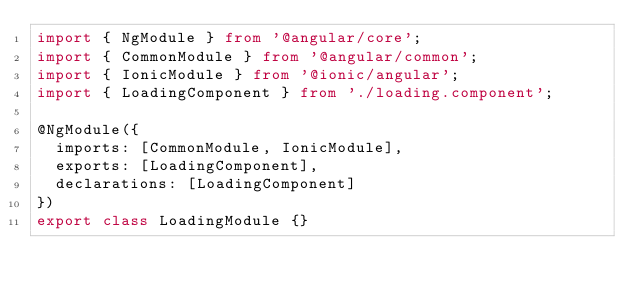<code> <loc_0><loc_0><loc_500><loc_500><_TypeScript_>import { NgModule } from '@angular/core';
import { CommonModule } from '@angular/common';
import { IonicModule } from '@ionic/angular';
import { LoadingComponent } from './loading.component';

@NgModule({
	imports: [CommonModule, IonicModule],
	exports: [LoadingComponent],
	declarations: [LoadingComponent]
})
export class LoadingModule {}
</code> 